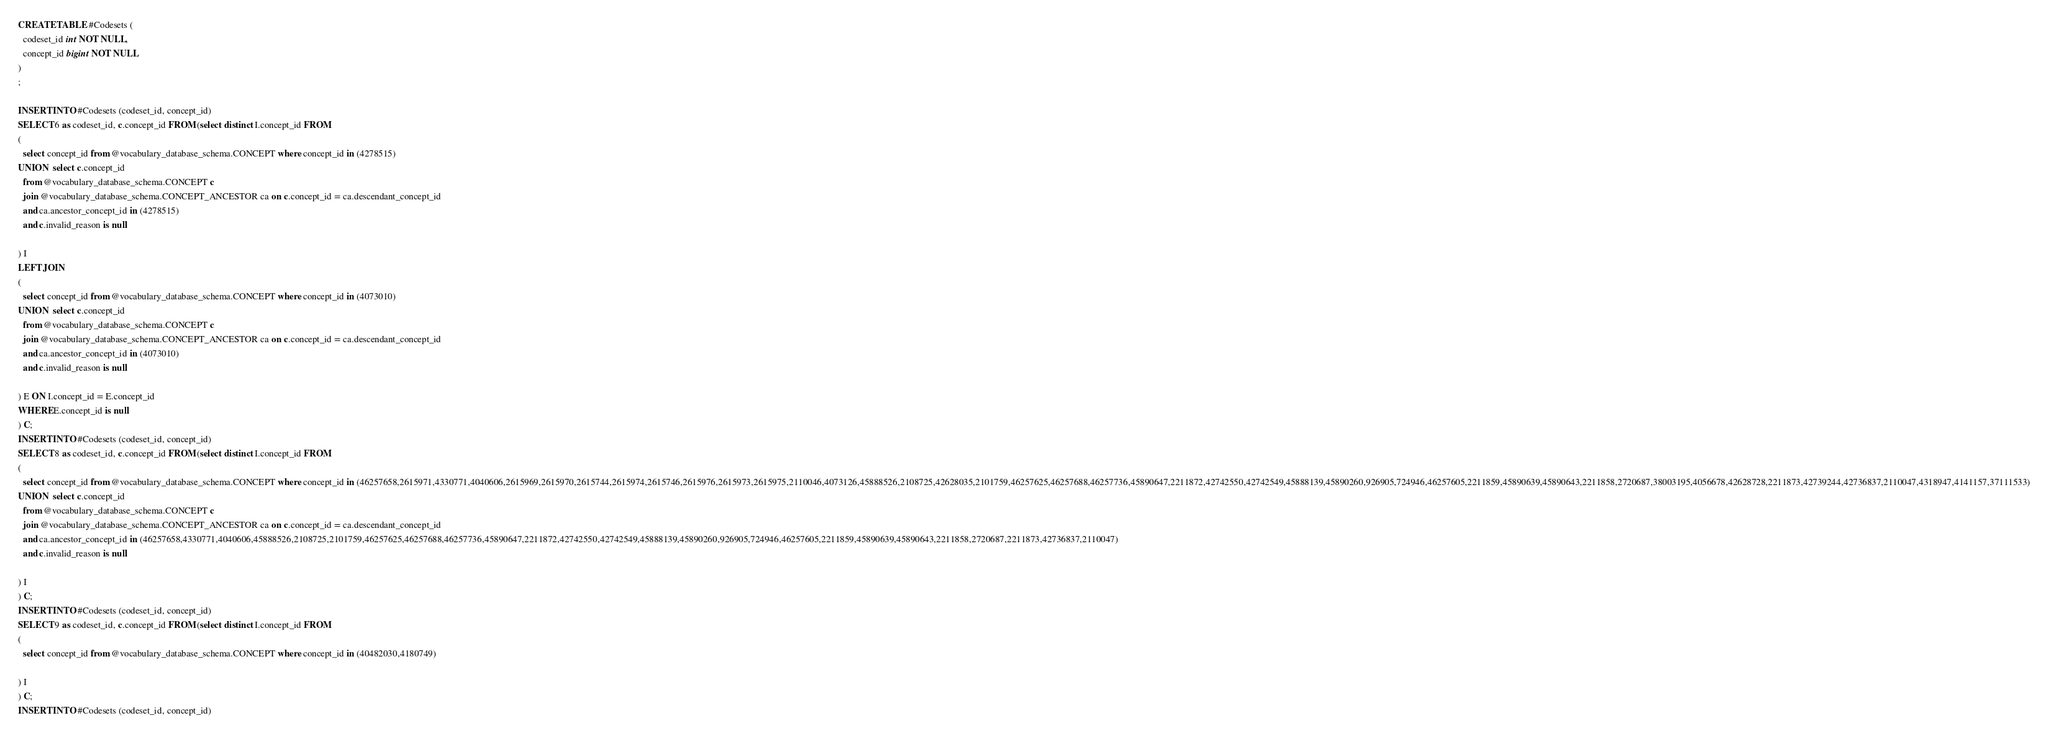Convert code to text. <code><loc_0><loc_0><loc_500><loc_500><_SQL_>CREATE TABLE #Codesets (
  codeset_id int NOT NULL,
  concept_id bigint NOT NULL
)
;

INSERT INTO #Codesets (codeset_id, concept_id)
SELECT 6 as codeset_id, c.concept_id FROM (select distinct I.concept_id FROM
( 
  select concept_id from @vocabulary_database_schema.CONCEPT where concept_id in (4278515)
UNION  select c.concept_id
  from @vocabulary_database_schema.CONCEPT c
  join @vocabulary_database_schema.CONCEPT_ANCESTOR ca on c.concept_id = ca.descendant_concept_id
  and ca.ancestor_concept_id in (4278515)
  and c.invalid_reason is null

) I
LEFT JOIN
(
  select concept_id from @vocabulary_database_schema.CONCEPT where concept_id in (4073010)
UNION  select c.concept_id
  from @vocabulary_database_schema.CONCEPT c
  join @vocabulary_database_schema.CONCEPT_ANCESTOR ca on c.concept_id = ca.descendant_concept_id
  and ca.ancestor_concept_id in (4073010)
  and c.invalid_reason is null

) E ON I.concept_id = E.concept_id
WHERE E.concept_id is null
) C;
INSERT INTO #Codesets (codeset_id, concept_id)
SELECT 8 as codeset_id, c.concept_id FROM (select distinct I.concept_id FROM
( 
  select concept_id from @vocabulary_database_schema.CONCEPT where concept_id in (46257658,2615971,4330771,4040606,2615969,2615970,2615744,2615974,2615746,2615976,2615973,2615975,2110046,4073126,45888526,2108725,42628035,2101759,46257625,46257688,46257736,45890647,2211872,42742550,42742549,45888139,45890260,926905,724946,46257605,2211859,45890639,45890643,2211858,2720687,38003195,4056678,42628728,2211873,42739244,42736837,2110047,4318947,4141157,37111533)
UNION  select c.concept_id
  from @vocabulary_database_schema.CONCEPT c
  join @vocabulary_database_schema.CONCEPT_ANCESTOR ca on c.concept_id = ca.descendant_concept_id
  and ca.ancestor_concept_id in (46257658,4330771,4040606,45888526,2108725,2101759,46257625,46257688,46257736,45890647,2211872,42742550,42742549,45888139,45890260,926905,724946,46257605,2211859,45890639,45890643,2211858,2720687,2211873,42736837,2110047)
  and c.invalid_reason is null

) I
) C;
INSERT INTO #Codesets (codeset_id, concept_id)
SELECT 9 as codeset_id, c.concept_id FROM (select distinct I.concept_id FROM
( 
  select concept_id from @vocabulary_database_schema.CONCEPT where concept_id in (40482030,4180749)

) I
) C;
INSERT INTO #Codesets (codeset_id, concept_id)</code> 